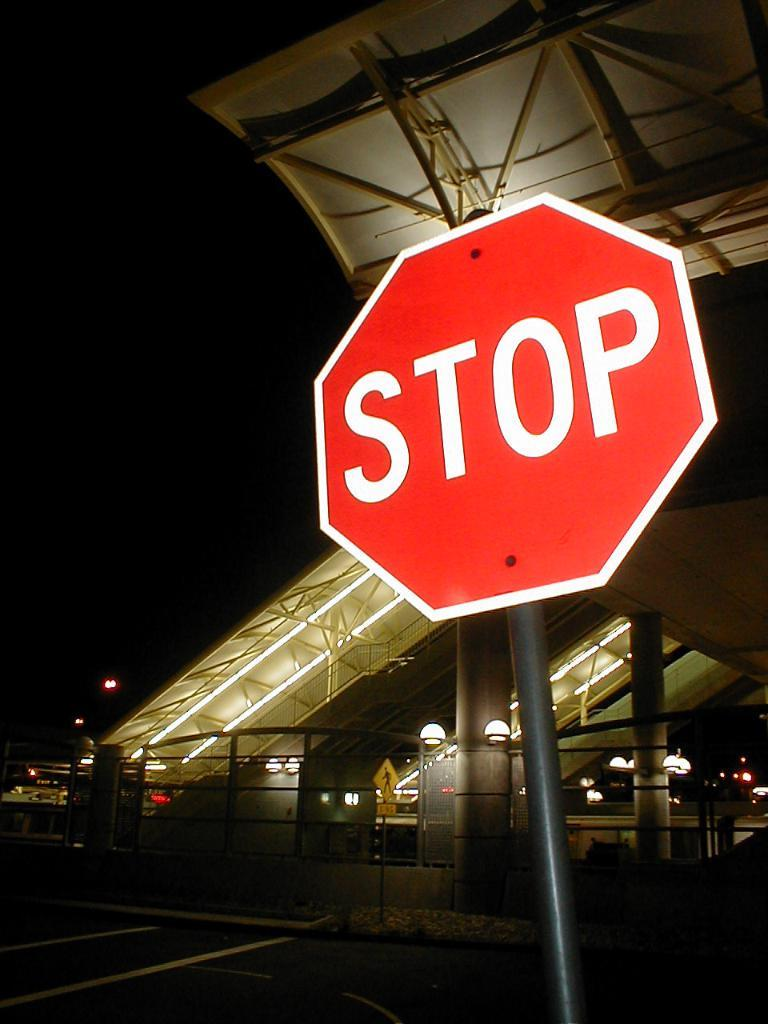<image>
Render a clear and concise summary of the photo. The road sign pictured in red is a stop sign. 